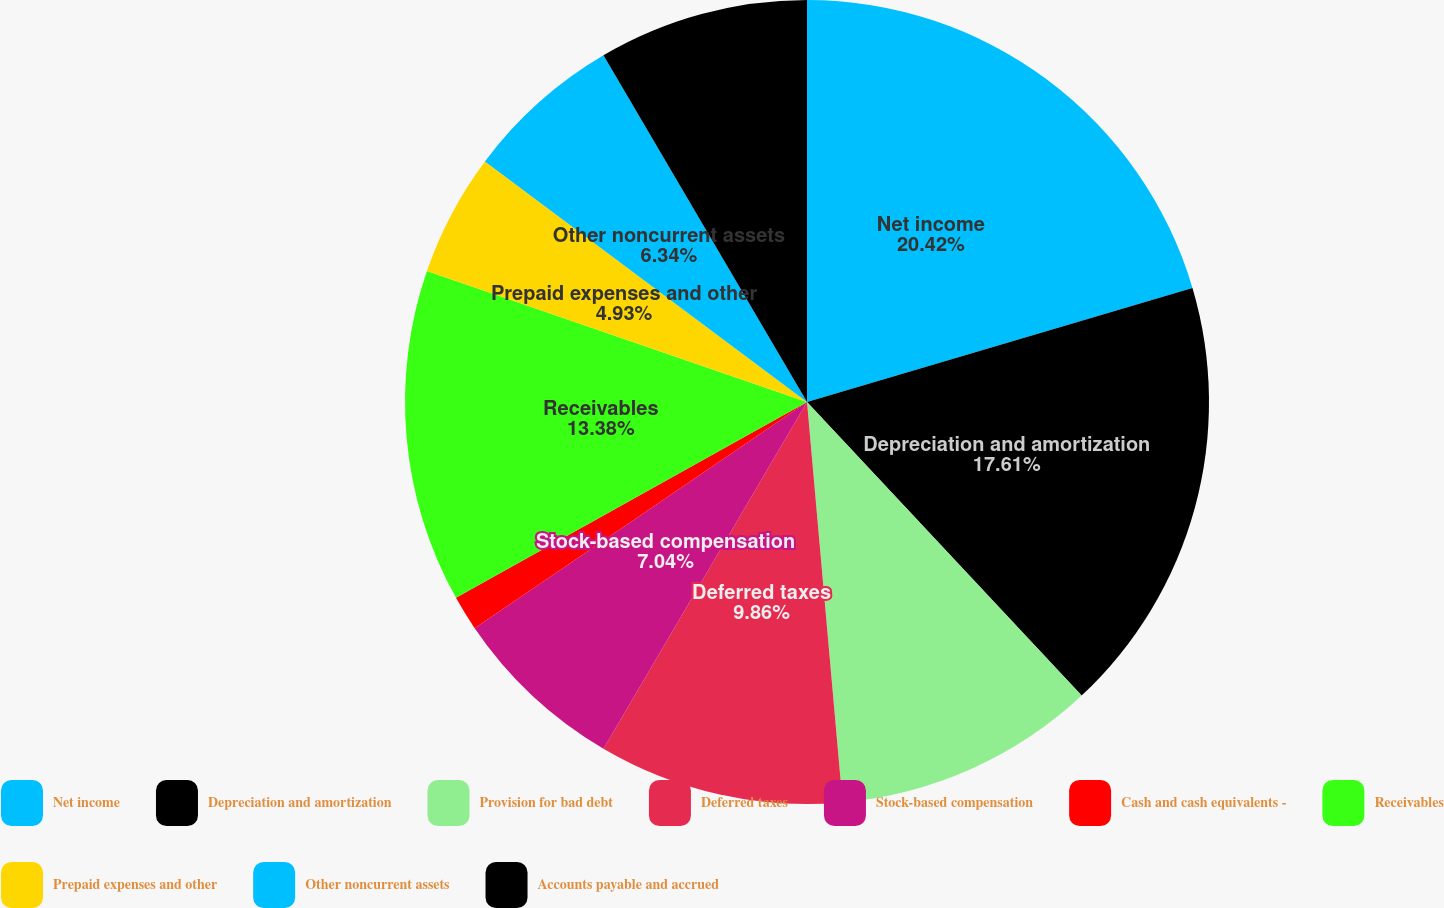Convert chart. <chart><loc_0><loc_0><loc_500><loc_500><pie_chart><fcel>Net income<fcel>Depreciation and amortization<fcel>Provision for bad debt<fcel>Deferred taxes<fcel>Stock-based compensation<fcel>Cash and cash equivalents -<fcel>Receivables<fcel>Prepaid expenses and other<fcel>Other noncurrent assets<fcel>Accounts payable and accrued<nl><fcel>20.42%<fcel>17.61%<fcel>10.56%<fcel>9.86%<fcel>7.04%<fcel>1.41%<fcel>13.38%<fcel>4.93%<fcel>6.34%<fcel>8.45%<nl></chart> 